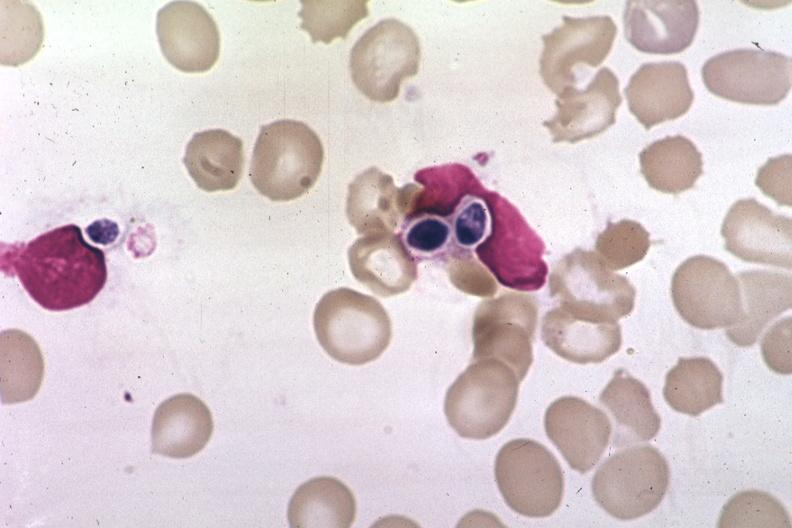what is present?
Answer the question using a single word or phrase. Blood 